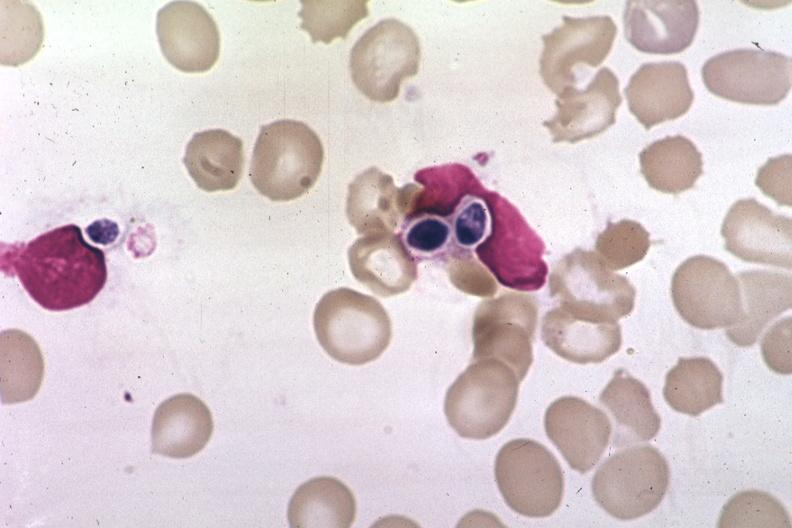what is present?
Answer the question using a single word or phrase. Blood 